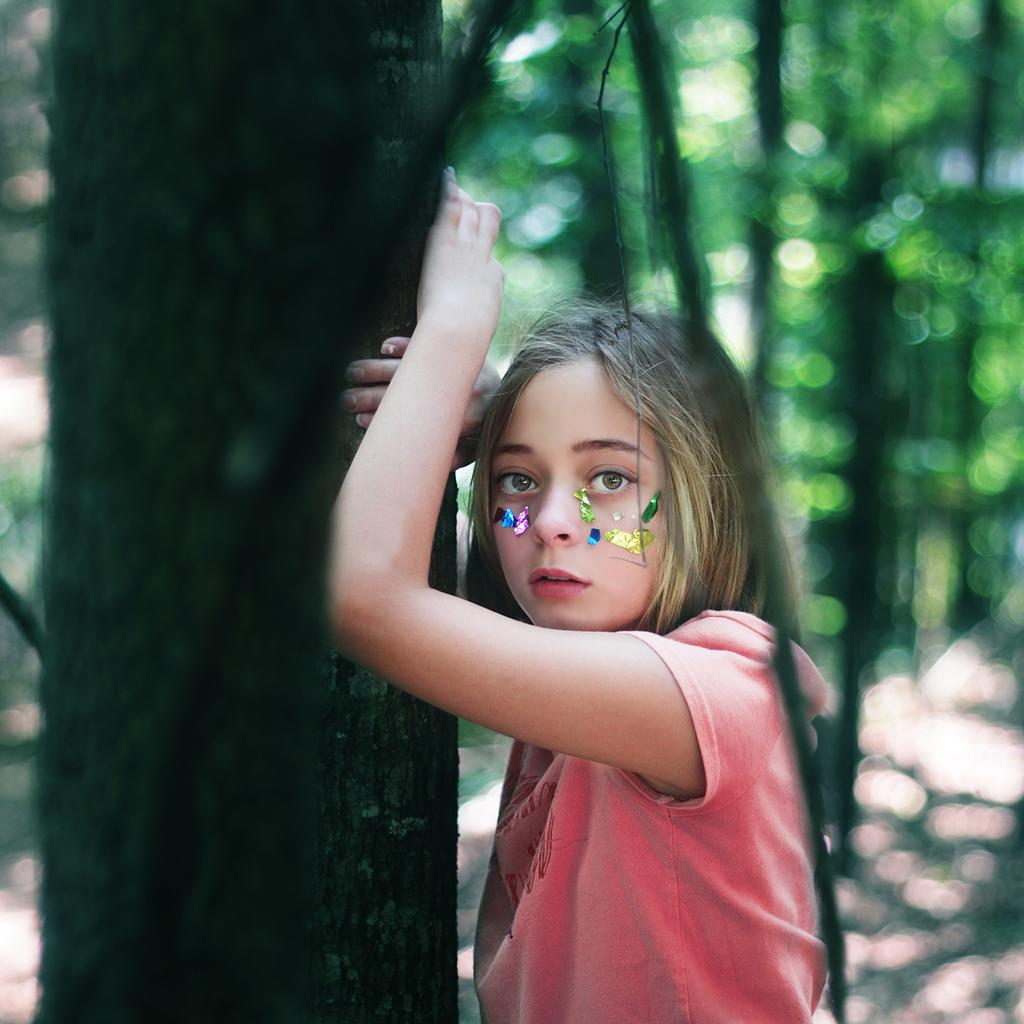Who is the main subject in the image? There is a girl in the image. What is the girl doing in the image? The girl is standing. What is the girl wearing in the image? The girl is wearing a t-shirt. What type of natural environment is visible in the image? There are trees in the image. What type of steel structure can be seen behind the girl in the image? There is no steel structure visible in the image; it only features a girl standing and trees in the background. 